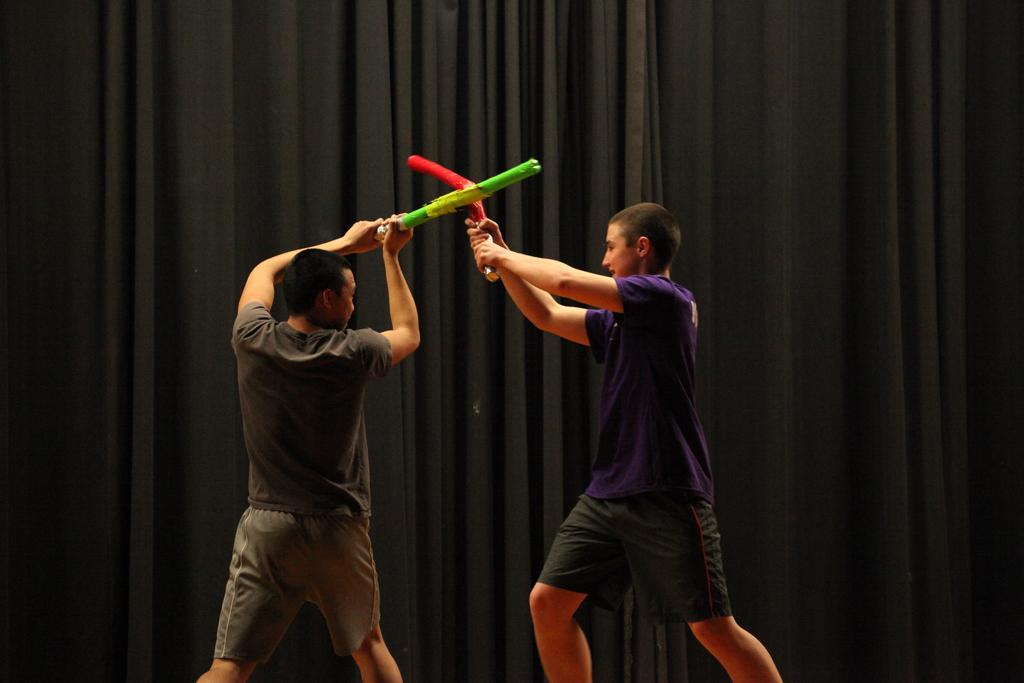How many people are in the image? There are two persons standing in the center of the image. What is the surface on which the persons are standing? The persons are standing on the floor. What can be seen in the background of the image? There is a curtain in the background of the image. What type of credit card is being used by the persons in the image? There is no credit card visible in the image, as the focus is on the two persons standing in the center. 